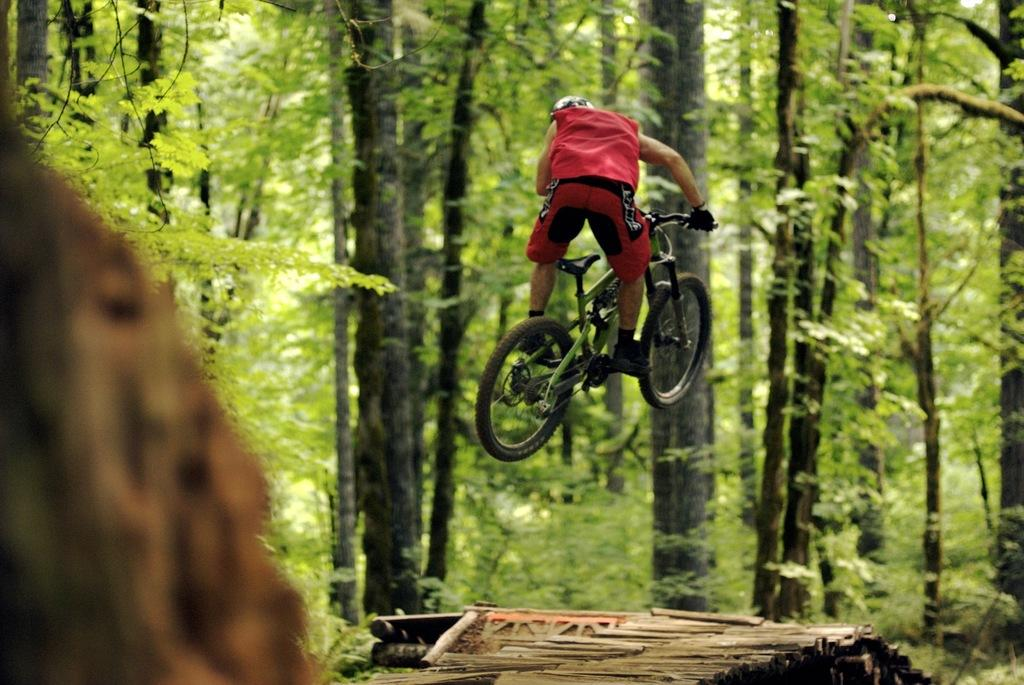Who is present in the image? There is a person in the image. What is the person doing in the image? The person is with a cycle. What can be seen in the background of the image? There are trees in the background of the image. What type of grass is being used as a prop in the image? There is no grass present in the image, and therefore no grass is being used as a prop. 